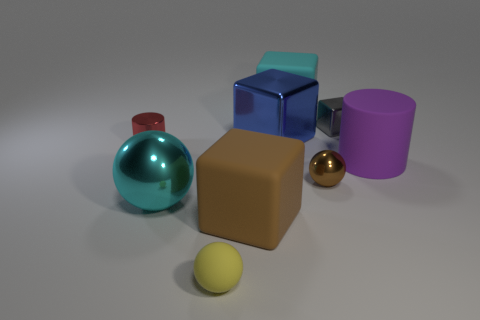What shape is the tiny metallic object that is both on the right side of the tiny red metal cylinder and in front of the big blue shiny object?
Offer a terse response. Sphere. Is the size of the brown ball the same as the gray block?
Offer a very short reply. Yes. There is a large brown rubber block; how many purple rubber cylinders are on the left side of it?
Give a very brief answer. 0. Is the number of cyan spheres on the left side of the tiny block the same as the number of small brown metal balls that are behind the tiny yellow matte sphere?
Ensure brevity in your answer.  Yes. There is a big object that is on the left side of the large brown matte block; does it have the same shape as the small red object?
Keep it short and to the point. No. There is a cyan ball; is its size the same as the rubber block that is behind the brown matte cube?
Ensure brevity in your answer.  Yes. How many other objects are there of the same color as the tiny cube?
Provide a succinct answer. 0. There is a tiny matte object; are there any big brown matte things behind it?
Ensure brevity in your answer.  Yes. What number of objects are blue shiny blocks or metallic objects that are to the right of the cyan metal object?
Provide a succinct answer. 3. Are there any tiny balls behind the ball that is left of the tiny yellow matte sphere?
Provide a short and direct response. Yes. 